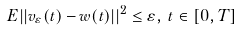Convert formula to latex. <formula><loc_0><loc_0><loc_500><loc_500>E | | v _ { \varepsilon } ( t ) - w ( t ) | | ^ { 2 } \leq \varepsilon , \, t \in [ 0 , T ]</formula> 